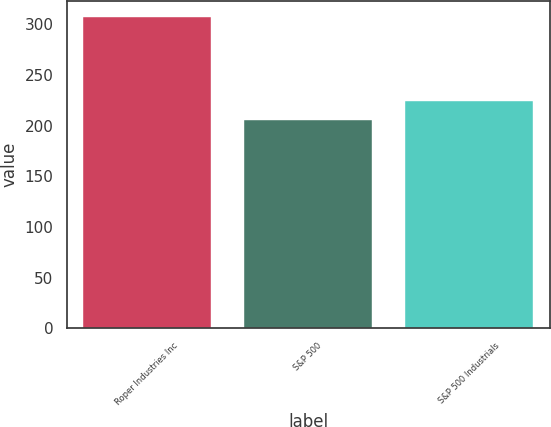Convert chart. <chart><loc_0><loc_0><loc_500><loc_500><bar_chart><fcel>Roper Industries Inc<fcel>S&P 500<fcel>S&P 500 Industrials<nl><fcel>307.29<fcel>205.14<fcel>224.52<nl></chart> 